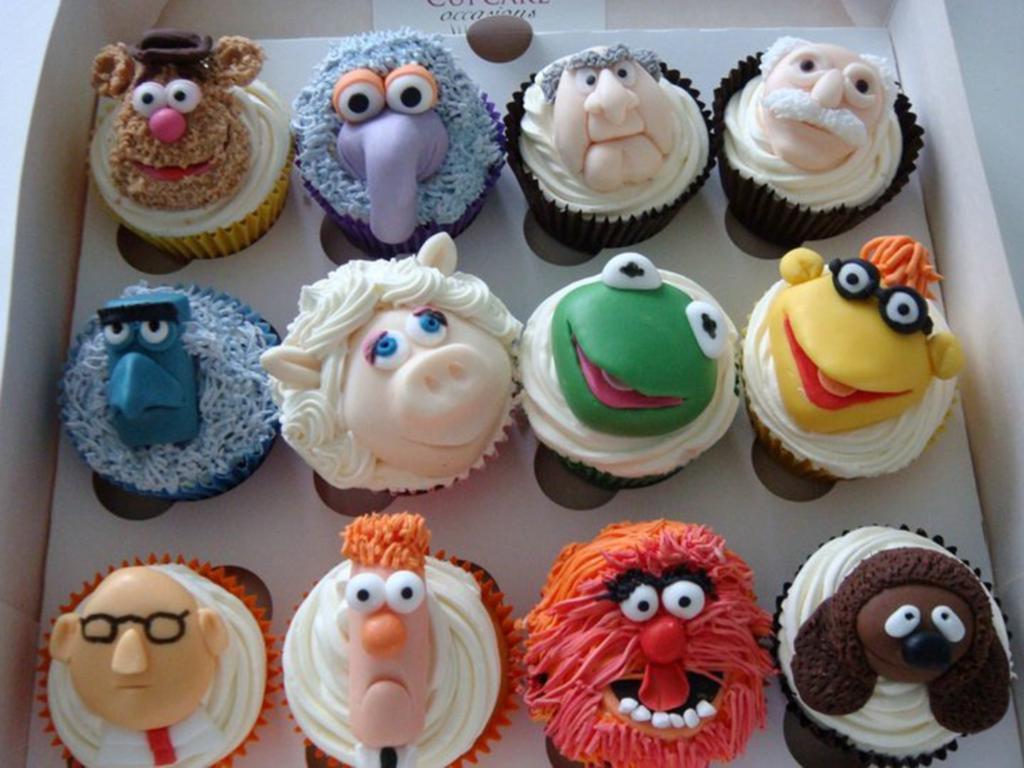Describe this image in one or two sentences. In the image we can see there are muffins decorated with cream as cartoon faces on it. The muffins are kept in the box. 